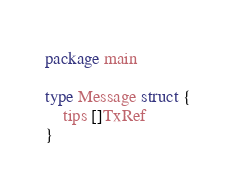<code> <loc_0><loc_0><loc_500><loc_500><_Go_>package main

type Message struct {
	tips []TxRef
}
</code> 